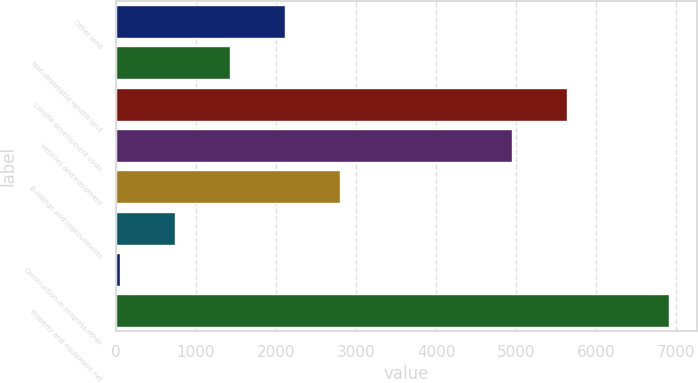Convert chart. <chart><loc_0><loc_0><loc_500><loc_500><bar_chart><fcel>Other land<fcel>Non-depletable landfill land<fcel>Landfill development costs<fcel>Vehicles and equipment<fcel>Buildings and improvements<fcel>Unnamed: 5<fcel>Construction-in-progress-other<fcel>Property and equipment net<nl><fcel>2110.4<fcel>1424.7<fcel>5632.1<fcel>4946.4<fcel>2796.1<fcel>739<fcel>53.3<fcel>6910.3<nl></chart> 